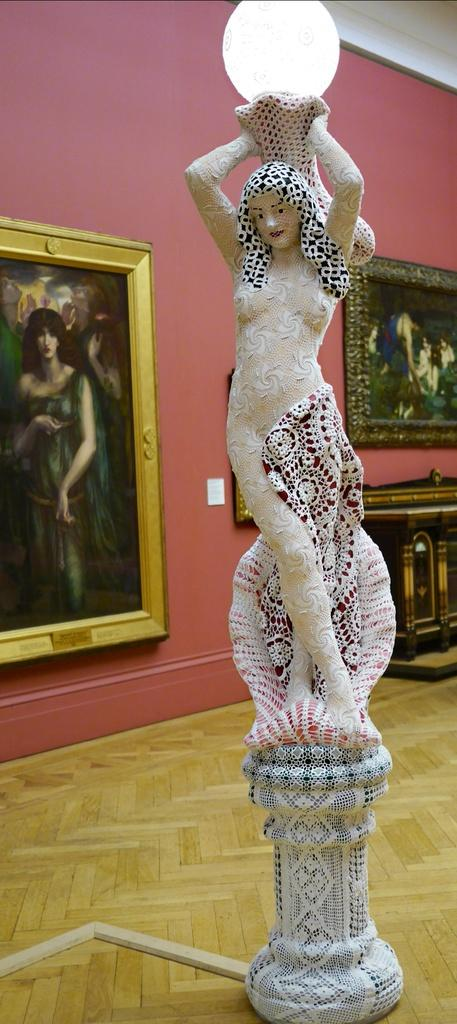What is the main subject of the image? There is a sculpture of a woman in the image. What is the woman holding in the sculpture? The woman is holding a light in the sculpture. What can be seen behind the sculpture? There is a wall behind the sculpture. What is on the wall? The wall has photo frames on it, and there is a painting on the wall. Can you tell me how many animals are visible in the zoo in the image? There is no zoo present in the image; it features a sculpture of a woman holding a light. What type of motion is the sculpture exhibiting in the image? The sculpture is a static object and does not exhibit any motion in the image. 